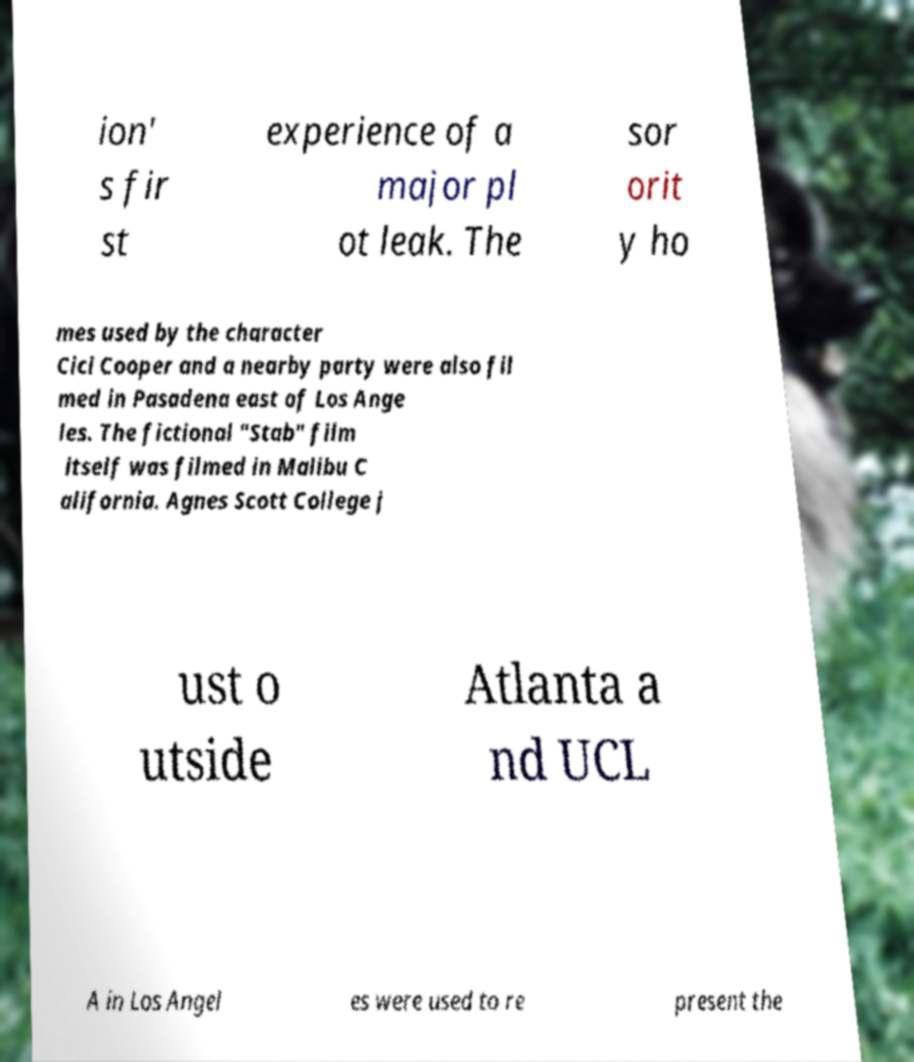For documentation purposes, I need the text within this image transcribed. Could you provide that? ion' s fir st experience of a major pl ot leak. The sor orit y ho mes used by the character Cici Cooper and a nearby party were also fil med in Pasadena east of Los Ange les. The fictional "Stab" film itself was filmed in Malibu C alifornia. Agnes Scott College j ust o utside Atlanta a nd UCL A in Los Angel es were used to re present the 